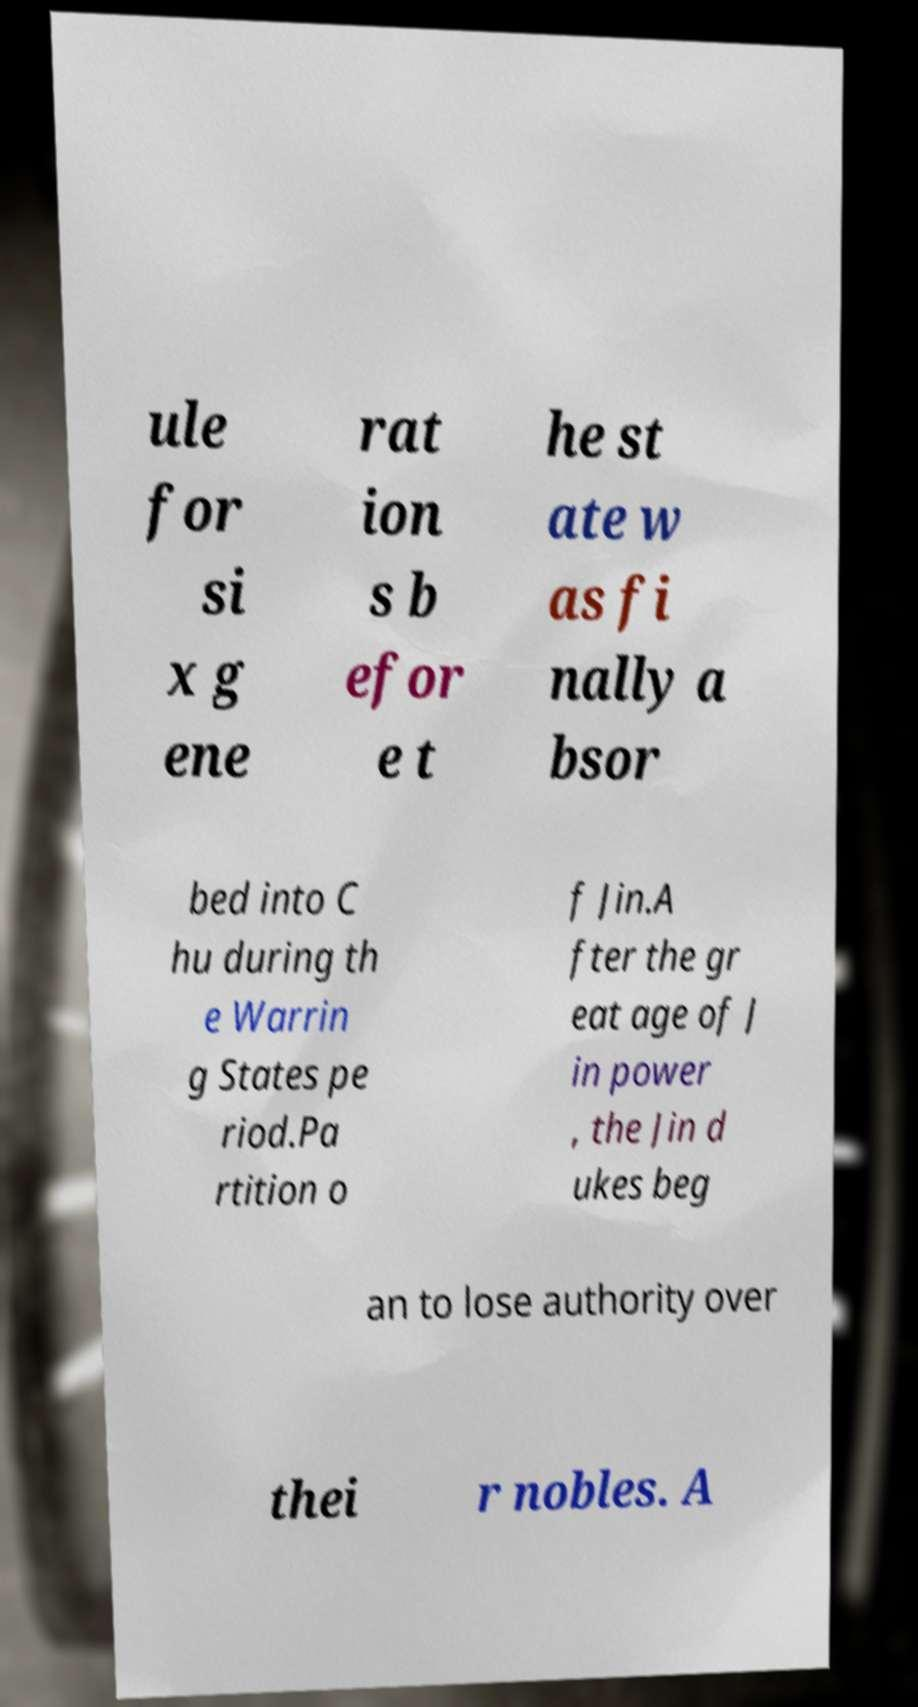I need the written content from this picture converted into text. Can you do that? ule for si x g ene rat ion s b efor e t he st ate w as fi nally a bsor bed into C hu during th e Warrin g States pe riod.Pa rtition o f Jin.A fter the gr eat age of J in power , the Jin d ukes beg an to lose authority over thei r nobles. A 